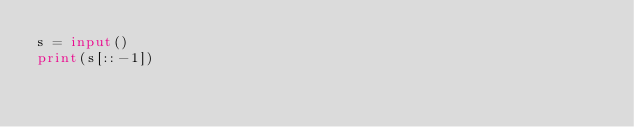<code> <loc_0><loc_0><loc_500><loc_500><_Python_>s = input()
print(s[::-1])</code> 